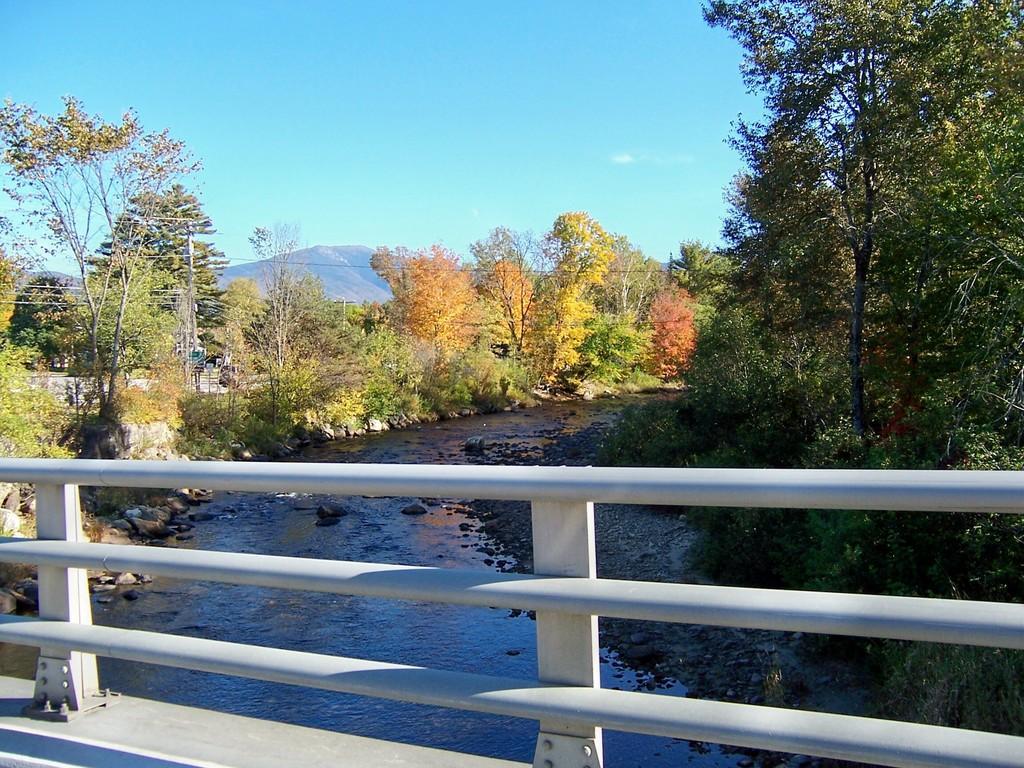Can you describe this image briefly? In this image I can see railing in the front and in the centre I can see the water. On the both side of the water I can see number of trees. On the left side of this image I can see few poles and few wires. In the background I can see the mountain and the sky. 